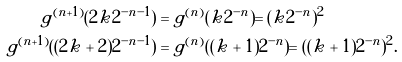<formula> <loc_0><loc_0><loc_500><loc_500>g ^ { ( n + 1 ) } ( 2 k 2 ^ { - n - 1 } ) & = g ^ { ( n ) } ( k 2 ^ { - n } ) = ( k 2 ^ { - n } ) ^ { 2 } \\ g ^ { ( n + 1 ) } ( ( 2 k + 2 ) 2 ^ { - n - 1 } ) & = g ^ { ( n ) } ( ( k + 1 ) 2 ^ { - n } ) = ( ( k + 1 ) 2 ^ { - n } ) ^ { 2 } .</formula> 